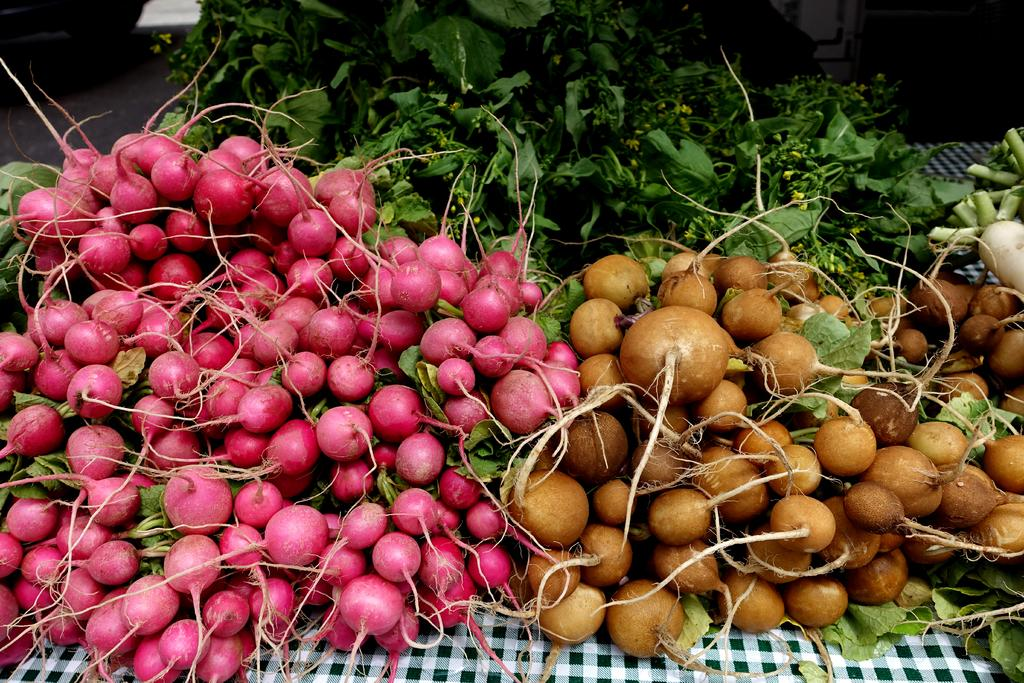What types of food can be seen on the table in the image? There are different types of vegetables on the table in the image. What is visible at the bottom of the image? There is a cloth visible at the bottom of the image. What can be seen in the top left corner of the image? There is a wheel on the road in the top left corner of the image. Is there a boat visible in the image? No, there is no boat present in the image. Can you see a kitty playing with an umbrella in the image? No, there is no kitty or umbrella present in the image. 